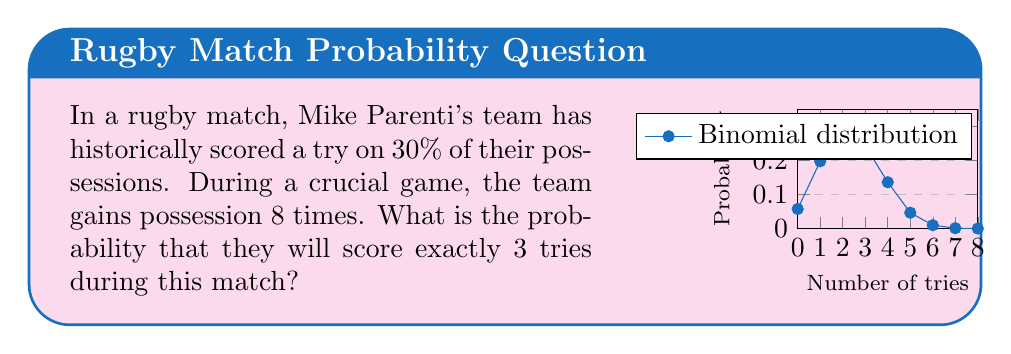Can you solve this math problem? To solve this problem, we'll use the binomial probability distribution, as we're dealing with a fixed number of independent trials (possessions) with two possible outcomes (try scored or not scored).

Let's define our variables:
- $n = 8$ (number of possessions)
- $p = 0.3$ (probability of scoring a try on a single possession)
- $k = 3$ (number of successes we're interested in)

The binomial probability formula is:

$$P(X = k) = \binom{n}{k} p^k (1-p)^{n-k}$$

Where $\binom{n}{k}$ is the binomial coefficient, calculated as:

$$\binom{n}{k} = \frac{n!}{k!(n-k)!}$$

Let's solve step by step:

1) Calculate the binomial coefficient:
   $$\binom{8}{3} = \frac{8!}{3!(8-3)!} = \frac{8!}{3!5!} = 56$$

2) Substitute all values into the binomial probability formula:
   $$P(X = 3) = 56 \cdot (0.3)^3 \cdot (1-0.3)^{8-3}$$

3) Simplify:
   $$P(X = 3) = 56 \cdot (0.3)^3 \cdot (0.7)^5$$

4) Calculate:
   $$P(X = 3) = 56 \cdot 0.027 \cdot 0.16807 \approx 0.2541$$

Therefore, the probability of scoring exactly 3 tries in 8 possessions is approximately 0.2541 or 25.41%.
Answer: $0.2541$ or $25.41\%$ 